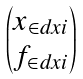Convert formula to latex. <formula><loc_0><loc_0><loc_500><loc_500>\begin{pmatrix} x _ { \in d x { i } } \\ f _ { \in d x { i } } \end{pmatrix}</formula> 